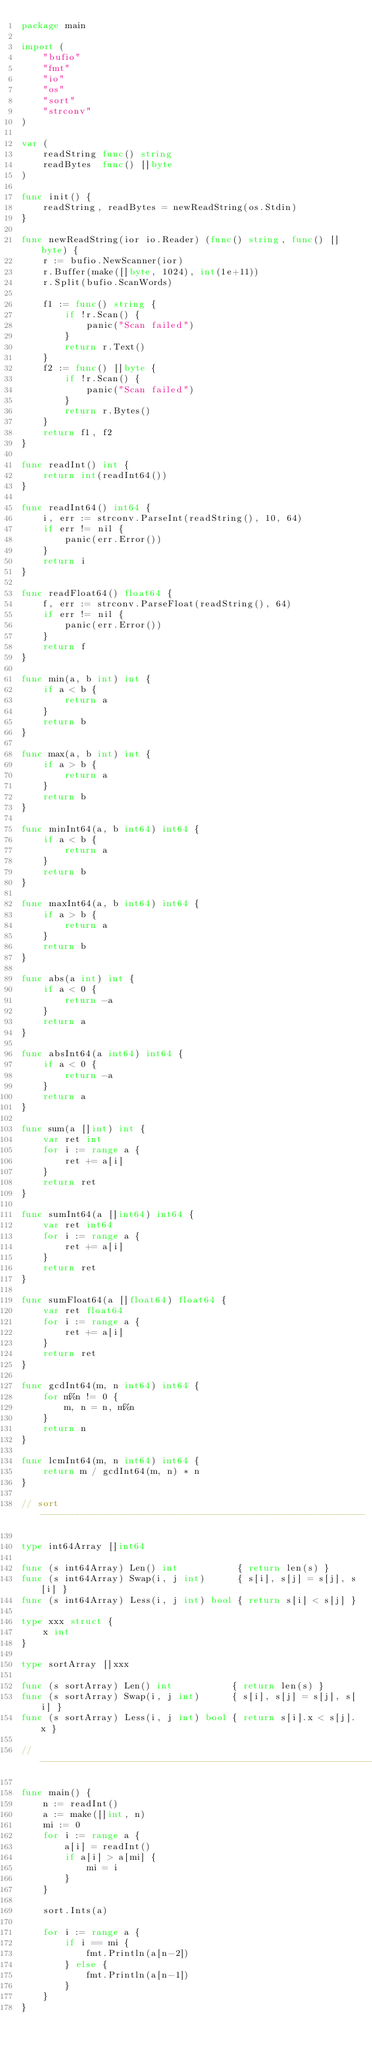Convert code to text. <code><loc_0><loc_0><loc_500><loc_500><_Go_>package main

import (
	"bufio"
	"fmt"
	"io"
	"os"
	"sort"
	"strconv"
)

var (
	readString func() string
	readBytes  func() []byte
)

func init() {
	readString, readBytes = newReadString(os.Stdin)
}

func newReadString(ior io.Reader) (func() string, func() []byte) {
	r := bufio.NewScanner(ior)
	r.Buffer(make([]byte, 1024), int(1e+11))
	r.Split(bufio.ScanWords)

	f1 := func() string {
		if !r.Scan() {
			panic("Scan failed")
		}
		return r.Text()
	}
	f2 := func() []byte {
		if !r.Scan() {
			panic("Scan failed")
		}
		return r.Bytes()
	}
	return f1, f2
}

func readInt() int {
	return int(readInt64())
}

func readInt64() int64 {
	i, err := strconv.ParseInt(readString(), 10, 64)
	if err != nil {
		panic(err.Error())
	}
	return i
}

func readFloat64() float64 {
	f, err := strconv.ParseFloat(readString(), 64)
	if err != nil {
		panic(err.Error())
	}
	return f
}

func min(a, b int) int {
	if a < b {
		return a
	}
	return b
}

func max(a, b int) int {
	if a > b {
		return a
	}
	return b
}

func minInt64(a, b int64) int64 {
	if a < b {
		return a
	}
	return b
}

func maxInt64(a, b int64) int64 {
	if a > b {
		return a
	}
	return b
}

func abs(a int) int {
	if a < 0 {
		return -a
	}
	return a
}

func absInt64(a int64) int64 {
	if a < 0 {
		return -a
	}
	return a
}

func sum(a []int) int {
	var ret int
	for i := range a {
		ret += a[i]
	}
	return ret
}

func sumInt64(a []int64) int64 {
	var ret int64
	for i := range a {
		ret += a[i]
	}
	return ret
}

func sumFloat64(a []float64) float64 {
	var ret float64
	for i := range a {
		ret += a[i]
	}
	return ret
}

func gcdInt64(m, n int64) int64 {
	for m%n != 0 {
		m, n = n, m%n
	}
	return n
}

func lcmInt64(m, n int64) int64 {
	return m / gcdInt64(m, n) * n
}

// sort ------------------------------------------------------------

type int64Array []int64

func (s int64Array) Len() int           { return len(s) }
func (s int64Array) Swap(i, j int)      { s[i], s[j] = s[j], s[i] }
func (s int64Array) Less(i, j int) bool { return s[i] < s[j] }

type xxx struct {
	x int
}

type sortArray []xxx

func (s sortArray) Len() int           { return len(s) }
func (s sortArray) Swap(i, j int)      { s[i], s[j] = s[j], s[i] }
func (s sortArray) Less(i, j int) bool { return s[i].x < s[j].x }

// -----------------------------------------------------------------

func main() {
	n := readInt()
	a := make([]int, n)
	mi := 0
	for i := range a {
		a[i] = readInt()
		if a[i] > a[mi] {
			mi = i
		}
	}

	sort.Ints(a)

	for i := range a {
		if i == mi {
			fmt.Println(a[n-2])
		} else {
			fmt.Println(a[n-1])
		}
	}
}
</code> 